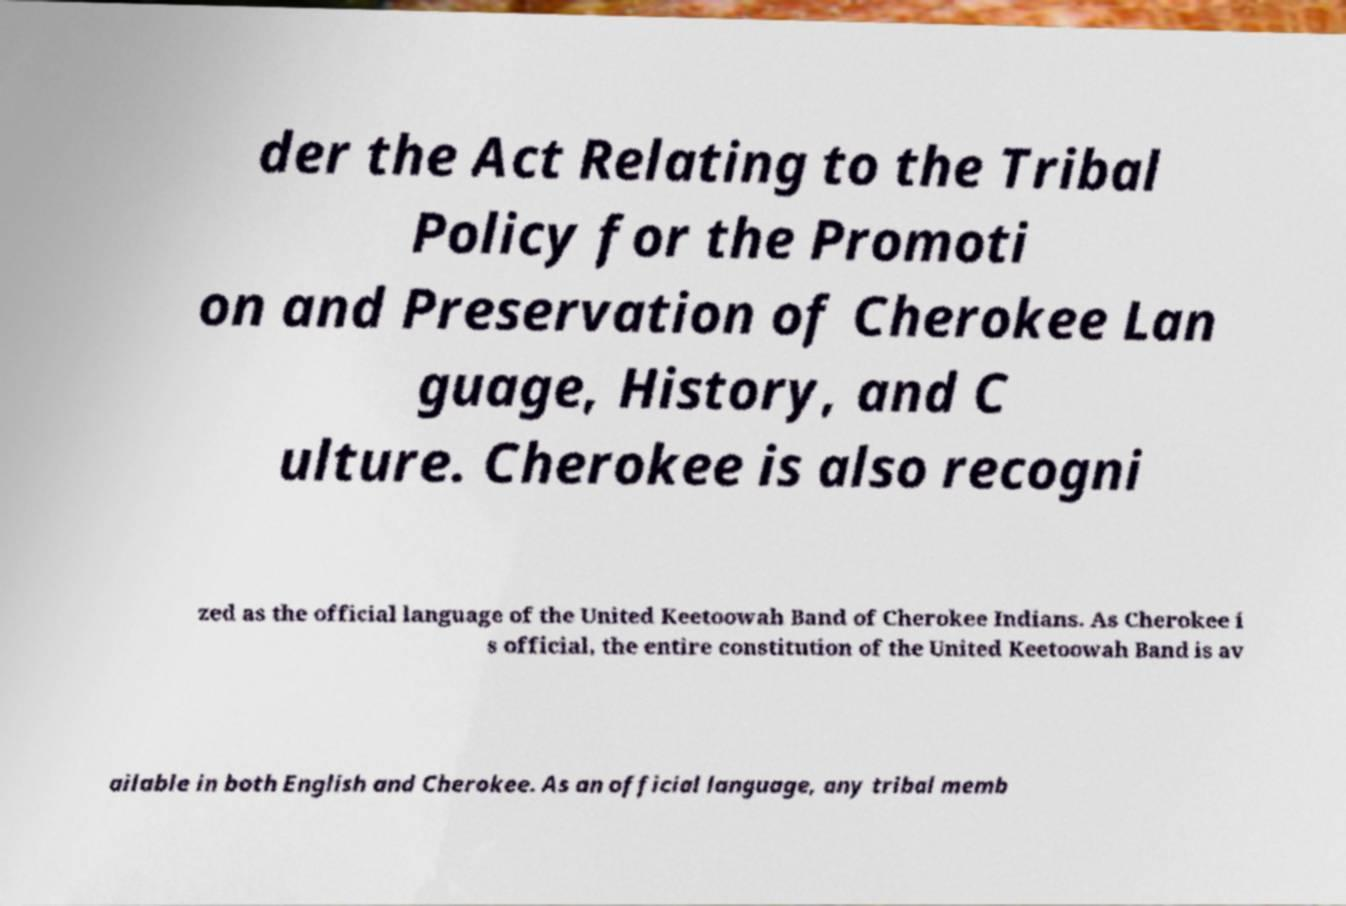For documentation purposes, I need the text within this image transcribed. Could you provide that? der the Act Relating to the Tribal Policy for the Promoti on and Preservation of Cherokee Lan guage, History, and C ulture. Cherokee is also recogni zed as the official language of the United Keetoowah Band of Cherokee Indians. As Cherokee i s official, the entire constitution of the United Keetoowah Band is av ailable in both English and Cherokee. As an official language, any tribal memb 